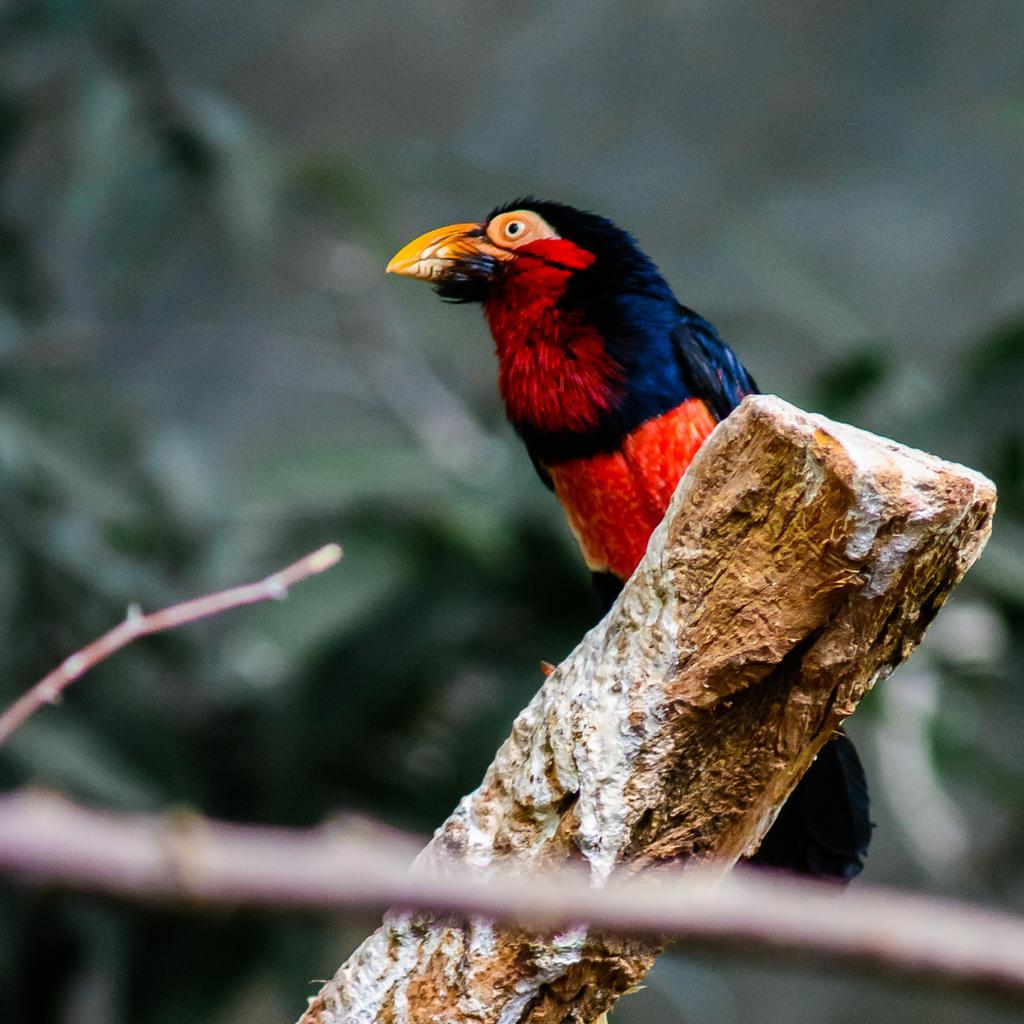Describe this image in one or two sentences. In this image there is a bird on the wooden stick. At the bottom there is a small wooden stick, In the background there are trees. 